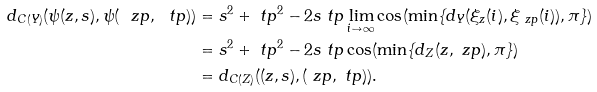<formula> <loc_0><loc_0><loc_500><loc_500>d _ { C ( Y ) } ( \psi ( z , s ) , \psi ( \ z p , \ t p ) ) & = s ^ { 2 } + \ t p ^ { 2 } - 2 s \ t p \lim _ { i \to \infty } \cos ( \min \{ d _ { Y } ( \xi _ { z } ( i ) , \xi _ { \ z p } ( i ) ) , \pi \} ) \\ & = s ^ { 2 } + \ t p ^ { 2 } - 2 s \ t p \cos ( \min \{ d _ { Z } ( z , \ z p ) , \pi \} ) \\ & = d _ { C ( Z ) } ( ( z , s ) , ( \ z p , \ t p ) ) .</formula> 